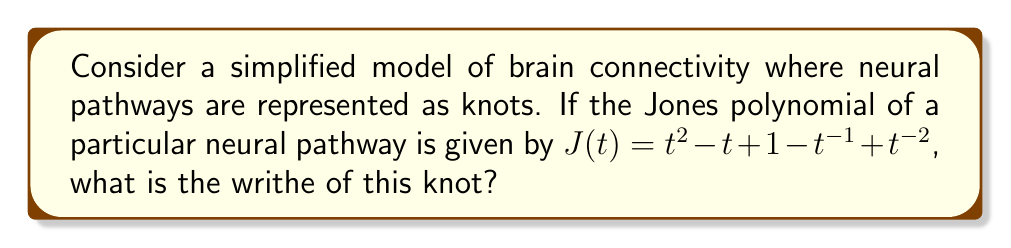Can you solve this math problem? To solve this problem, we'll follow these steps:

1) The Jones polynomial is a knot invariant that can be related to the writhe of a knot. The writhe is a measure of the signed crossing number of a knot diagram.

2) For alternating knots, there's a relationship between the Jones polynomial and the writhe. Specifically, the lowest exponent in the Jones polynomial is related to the writhe.

3) In this case, the Jones polynomial is:

   $J(t) = t^2 - t + 1 - t^{-1} + t^{-2}$

4) The lowest exponent in this polynomial is -2.

5) For alternating knots, the writhe (w) is related to the lowest exponent (e) in the Jones polynomial by the formula:

   $w = -e - 1$

6) Substituting our lowest exponent (-2) into this formula:

   $w = -(-2) - 1 = 2 - 1 = 1$

7) Therefore, the writhe of this knot is 1.

This result suggests that in this simplified model of brain connectivity, the neural pathway represented by this knot has a net positive crossing when projected onto a 2D plane. In the context of brain connectivity, this could potentially indicate a more complex or intertwined pathway.
Answer: 1 